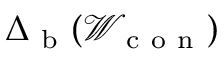<formula> <loc_0><loc_0><loc_500><loc_500>\Delta _ { b } ( \mathcal { W } _ { c o n } )</formula> 